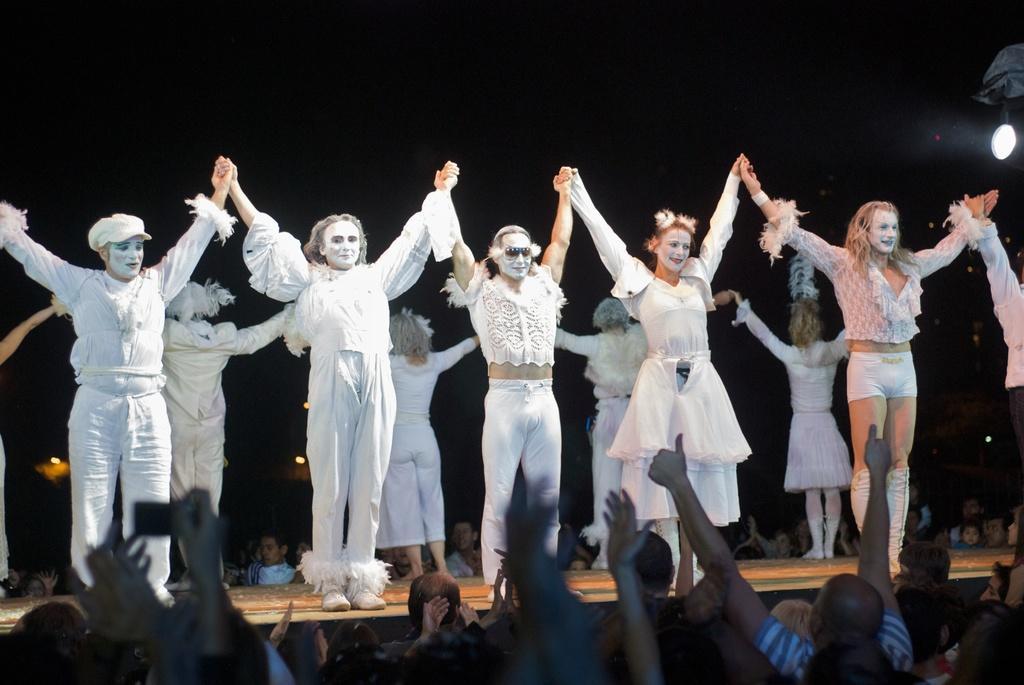Could you give a brief overview of what you see in this image? In this picture we can see people wearing costumes and standing on the stage. They all are holding and raising their hands. We can see the crowd. Background portion of the picture is dark. We can see lights.  In the front portion of the image we can see few people are raising their hands and one person is holding an object. 